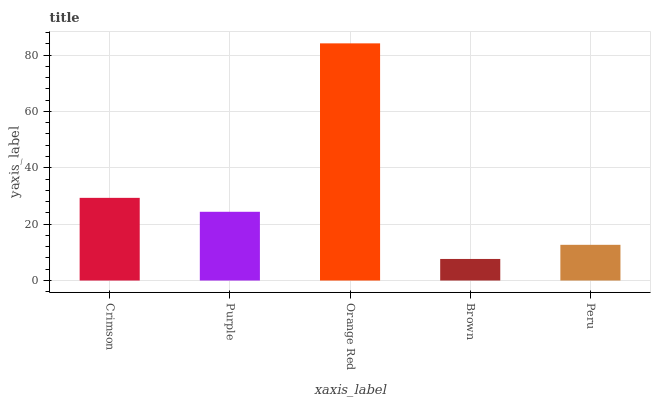Is Brown the minimum?
Answer yes or no. Yes. Is Orange Red the maximum?
Answer yes or no. Yes. Is Purple the minimum?
Answer yes or no. No. Is Purple the maximum?
Answer yes or no. No. Is Crimson greater than Purple?
Answer yes or no. Yes. Is Purple less than Crimson?
Answer yes or no. Yes. Is Purple greater than Crimson?
Answer yes or no. No. Is Crimson less than Purple?
Answer yes or no. No. Is Purple the high median?
Answer yes or no. Yes. Is Purple the low median?
Answer yes or no. Yes. Is Brown the high median?
Answer yes or no. No. Is Crimson the low median?
Answer yes or no. No. 